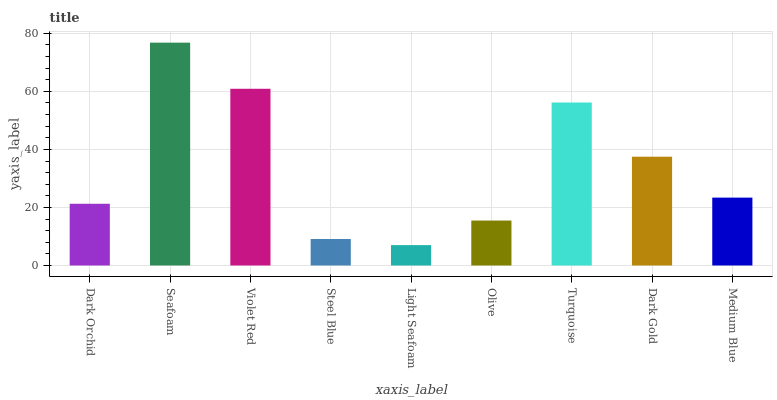Is Violet Red the minimum?
Answer yes or no. No. Is Violet Red the maximum?
Answer yes or no. No. Is Seafoam greater than Violet Red?
Answer yes or no. Yes. Is Violet Red less than Seafoam?
Answer yes or no. Yes. Is Violet Red greater than Seafoam?
Answer yes or no. No. Is Seafoam less than Violet Red?
Answer yes or no. No. Is Medium Blue the high median?
Answer yes or no. Yes. Is Medium Blue the low median?
Answer yes or no. Yes. Is Dark Orchid the high median?
Answer yes or no. No. Is Dark Gold the low median?
Answer yes or no. No. 